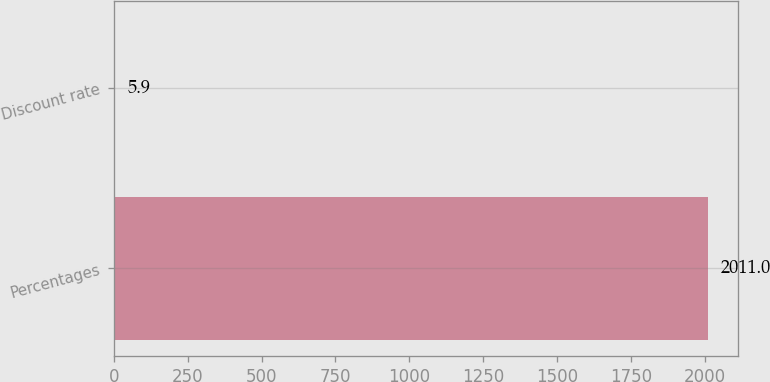Convert chart to OTSL. <chart><loc_0><loc_0><loc_500><loc_500><bar_chart><fcel>Percentages<fcel>Discount rate<nl><fcel>2011<fcel>5.9<nl></chart> 